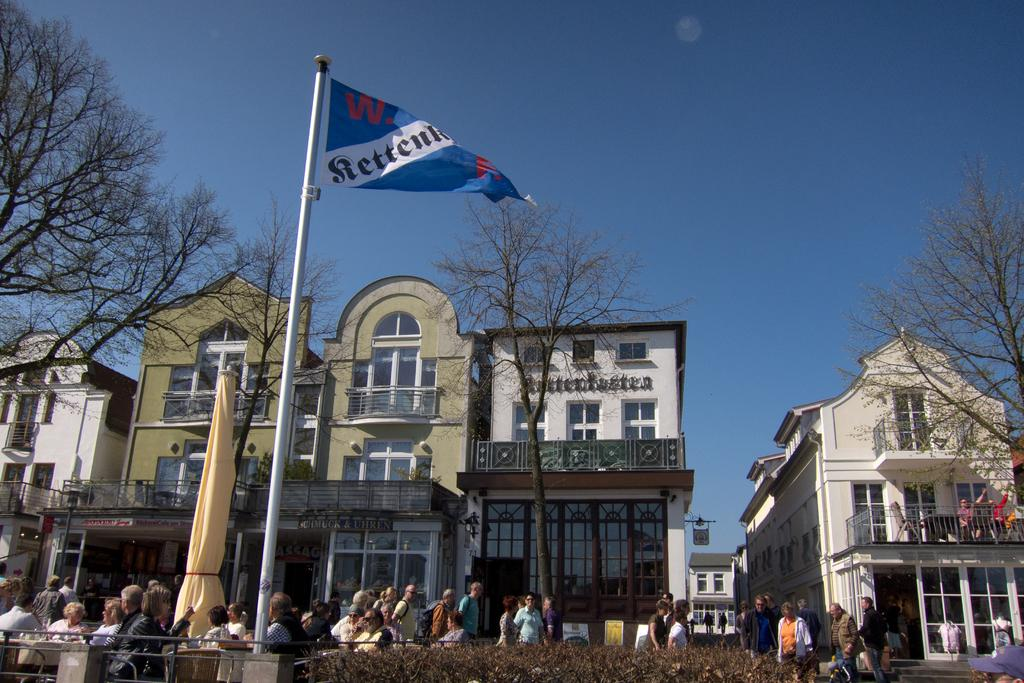What type of structures are present in the image? There are buildings with windows and doors in the image. Can you describe any architectural features in the image? Yes, there are stairs visible in the image. What type of enclosure is present in the image? There is fencing in the image. Are there any vertical structures in the image? Yes, there are poles in the image. What type of decorative elements can be seen in the image? There are flags in the image. What type of vegetation is present in the image? There are dry trees and plants in the image. What part of the natural environment is visible in the image? The sky is visible in the image. What type of noise can be heard coming from the nation in the image? There is no nation present in the image, and therefore no noise can be heard coming from it. What shape is the circle in the image? There is no circle present in the image. 